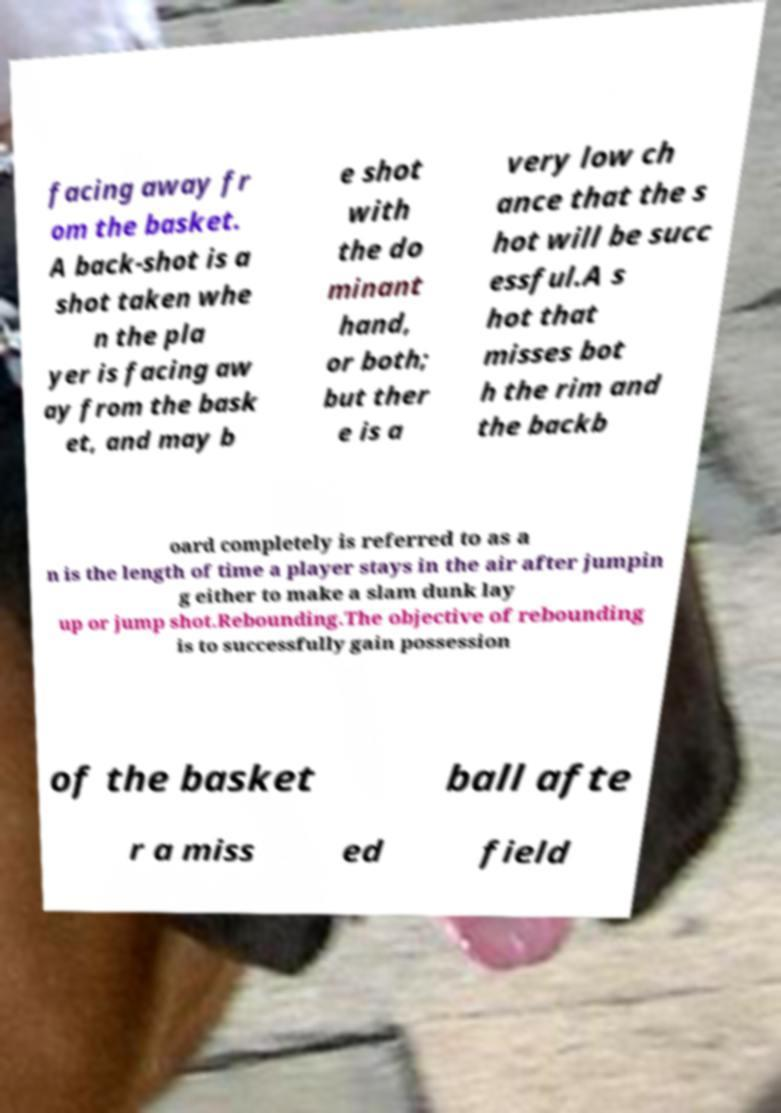For documentation purposes, I need the text within this image transcribed. Could you provide that? facing away fr om the basket. A back-shot is a shot taken whe n the pla yer is facing aw ay from the bask et, and may b e shot with the do minant hand, or both; but ther e is a very low ch ance that the s hot will be succ essful.A s hot that misses bot h the rim and the backb oard completely is referred to as a n is the length of time a player stays in the air after jumpin g either to make a slam dunk lay up or jump shot.Rebounding.The objective of rebounding is to successfully gain possession of the basket ball afte r a miss ed field 